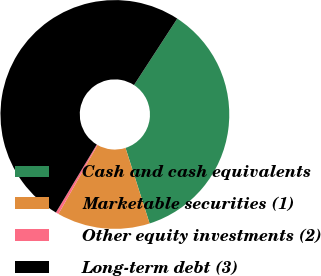Convert chart to OTSL. <chart><loc_0><loc_0><loc_500><loc_500><pie_chart><fcel>Cash and cash equivalents<fcel>Marketable securities (1)<fcel>Other equity investments (2)<fcel>Long-term debt (3)<nl><fcel>35.91%<fcel>13.12%<fcel>0.41%<fcel>50.56%<nl></chart> 